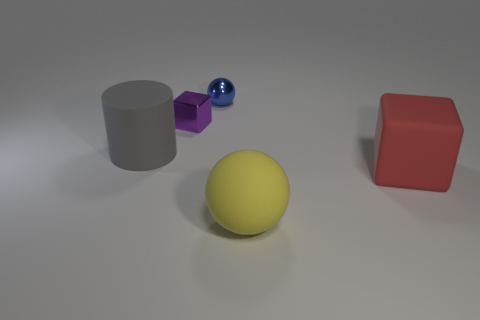What is the material of the other thing that is the same shape as the large yellow object?
Your answer should be compact. Metal. Is the material of the big yellow thing the same as the red block?
Your answer should be very brief. Yes. Is the number of things to the left of the large ball greater than the number of large matte things?
Provide a short and direct response. No. There is a block that is on the right side of the sphere that is in front of the large rubber object left of the tiny purple block; what is it made of?
Ensure brevity in your answer.  Rubber. What number of objects are small purple metal things or spheres that are behind the tiny cube?
Provide a succinct answer. 2. There is a ball to the left of the big yellow matte object; does it have the same color as the matte sphere?
Keep it short and to the point. No. Are there more matte cylinders that are behind the tiny block than big gray objects that are to the right of the large red matte object?
Ensure brevity in your answer.  No. Is there anything else that is the same color as the tiny shiny cube?
Ensure brevity in your answer.  No. How many things are tiny green rubber things or big matte things?
Keep it short and to the point. 3. There is a rubber thing behind the red matte thing; is its size the same as the yellow rubber object?
Give a very brief answer. Yes. 